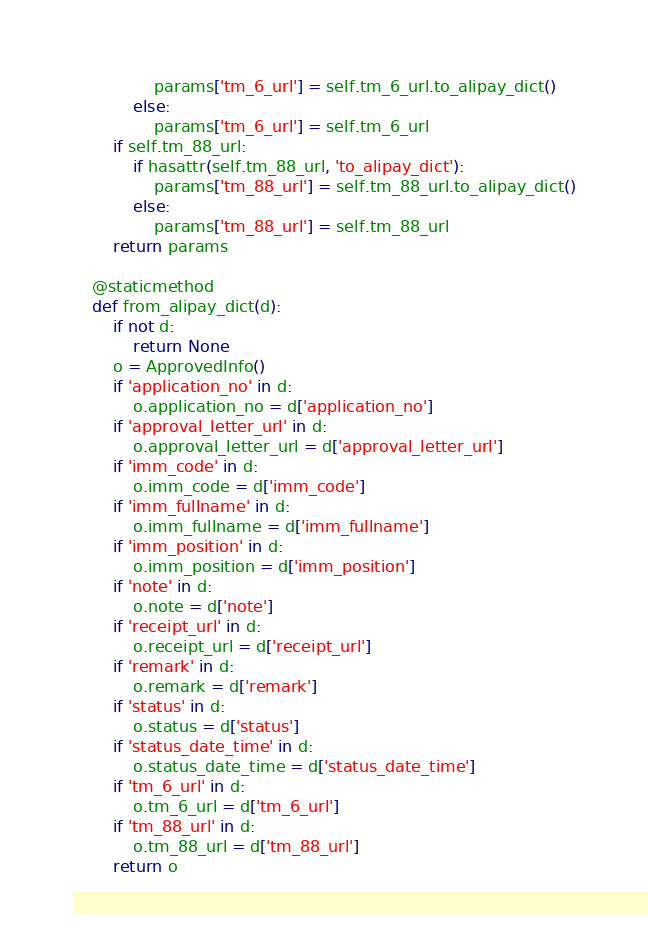<code> <loc_0><loc_0><loc_500><loc_500><_Python_>                params['tm_6_url'] = self.tm_6_url.to_alipay_dict()
            else:
                params['tm_6_url'] = self.tm_6_url
        if self.tm_88_url:
            if hasattr(self.tm_88_url, 'to_alipay_dict'):
                params['tm_88_url'] = self.tm_88_url.to_alipay_dict()
            else:
                params['tm_88_url'] = self.tm_88_url
        return params

    @staticmethod
    def from_alipay_dict(d):
        if not d:
            return None
        o = ApprovedInfo()
        if 'application_no' in d:
            o.application_no = d['application_no']
        if 'approval_letter_url' in d:
            o.approval_letter_url = d['approval_letter_url']
        if 'imm_code' in d:
            o.imm_code = d['imm_code']
        if 'imm_fullname' in d:
            o.imm_fullname = d['imm_fullname']
        if 'imm_position' in d:
            o.imm_position = d['imm_position']
        if 'note' in d:
            o.note = d['note']
        if 'receipt_url' in d:
            o.receipt_url = d['receipt_url']
        if 'remark' in d:
            o.remark = d['remark']
        if 'status' in d:
            o.status = d['status']
        if 'status_date_time' in d:
            o.status_date_time = d['status_date_time']
        if 'tm_6_url' in d:
            o.tm_6_url = d['tm_6_url']
        if 'tm_88_url' in d:
            o.tm_88_url = d['tm_88_url']
        return o


</code> 